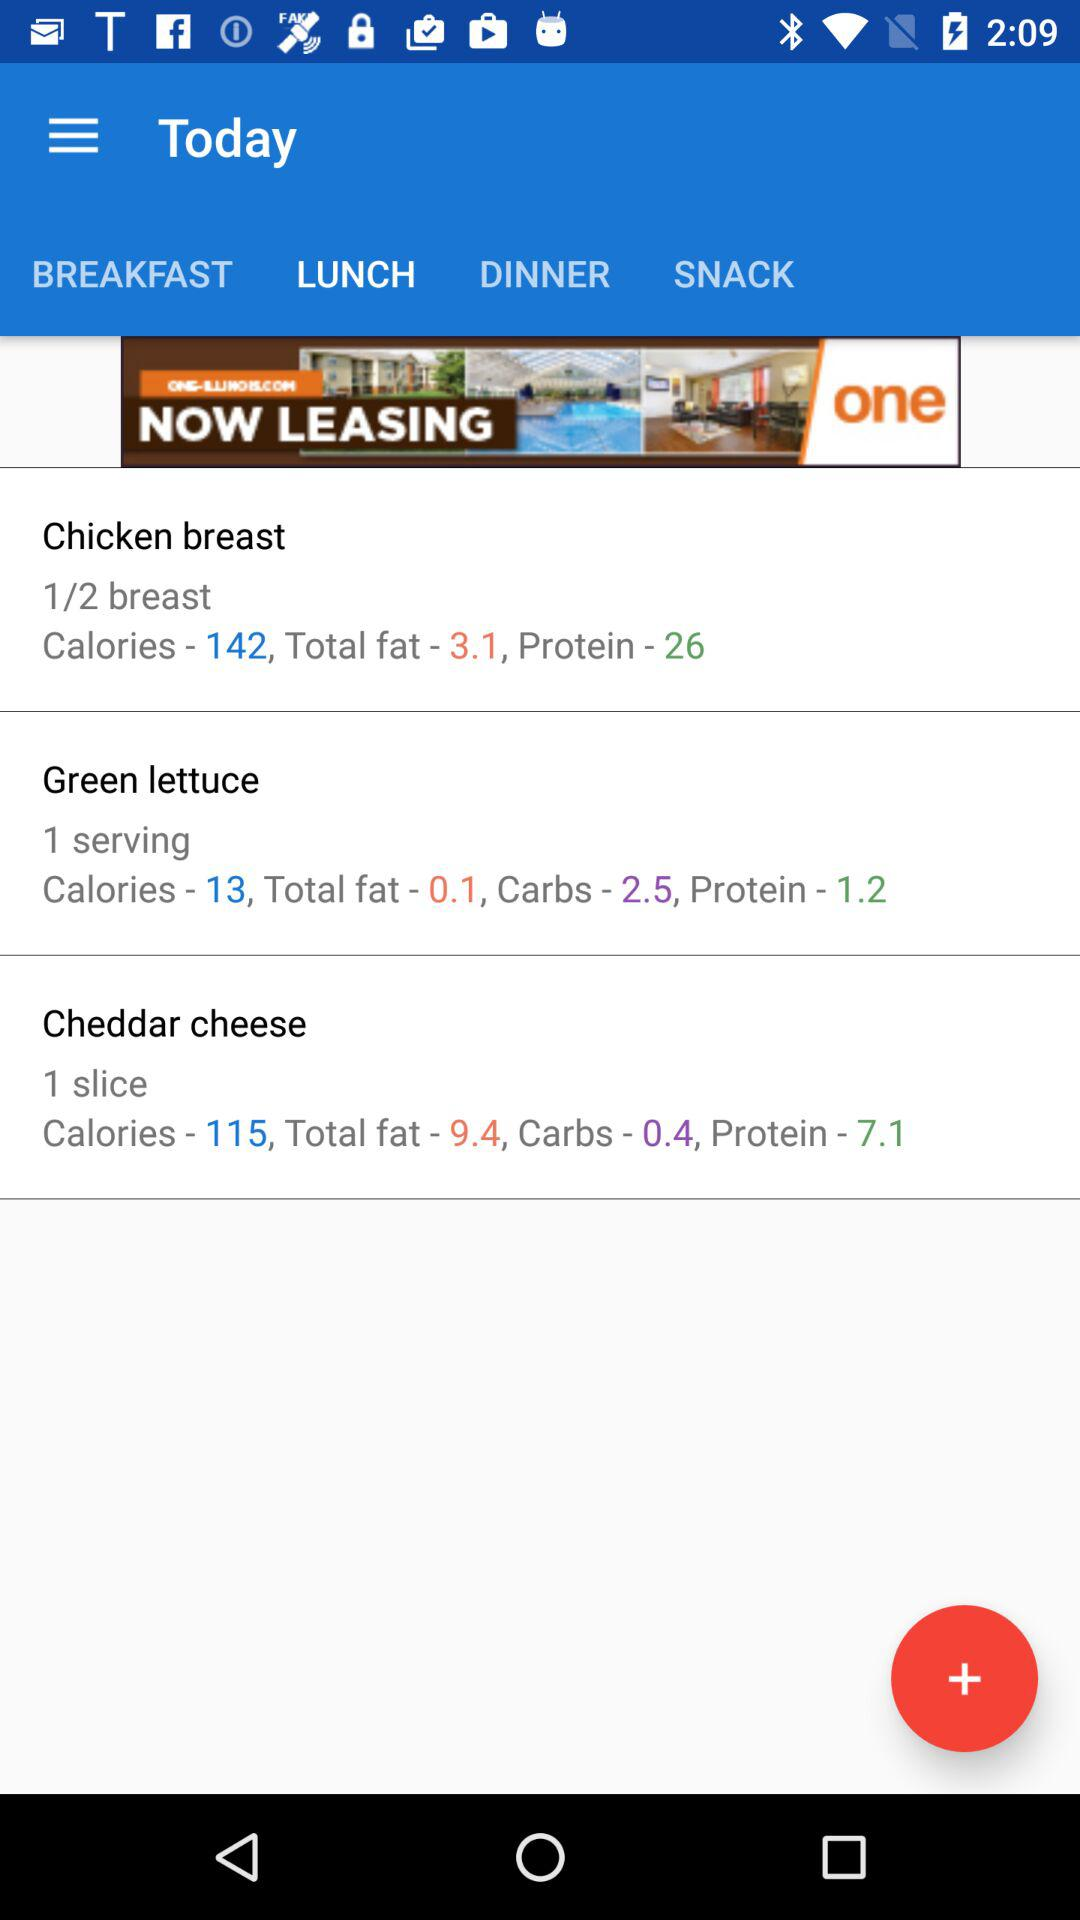What is the total amount of protein in "Chicken breast"? The total amount of protein in "Chicken breast" is 26. 